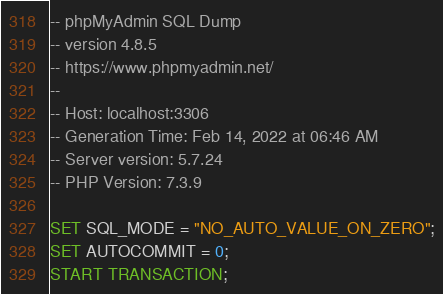<code> <loc_0><loc_0><loc_500><loc_500><_SQL_>-- phpMyAdmin SQL Dump
-- version 4.8.5
-- https://www.phpmyadmin.net/
--
-- Host: localhost:3306
-- Generation Time: Feb 14, 2022 at 06:46 AM
-- Server version: 5.7.24
-- PHP Version: 7.3.9

SET SQL_MODE = "NO_AUTO_VALUE_ON_ZERO";
SET AUTOCOMMIT = 0;
START TRANSACTION;</code> 